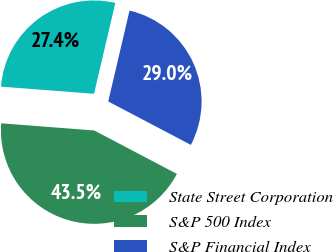<chart> <loc_0><loc_0><loc_500><loc_500><pie_chart><fcel>State Street Corporation<fcel>S&P 500 Index<fcel>S&P Financial Index<nl><fcel>27.44%<fcel>43.52%<fcel>29.04%<nl></chart> 